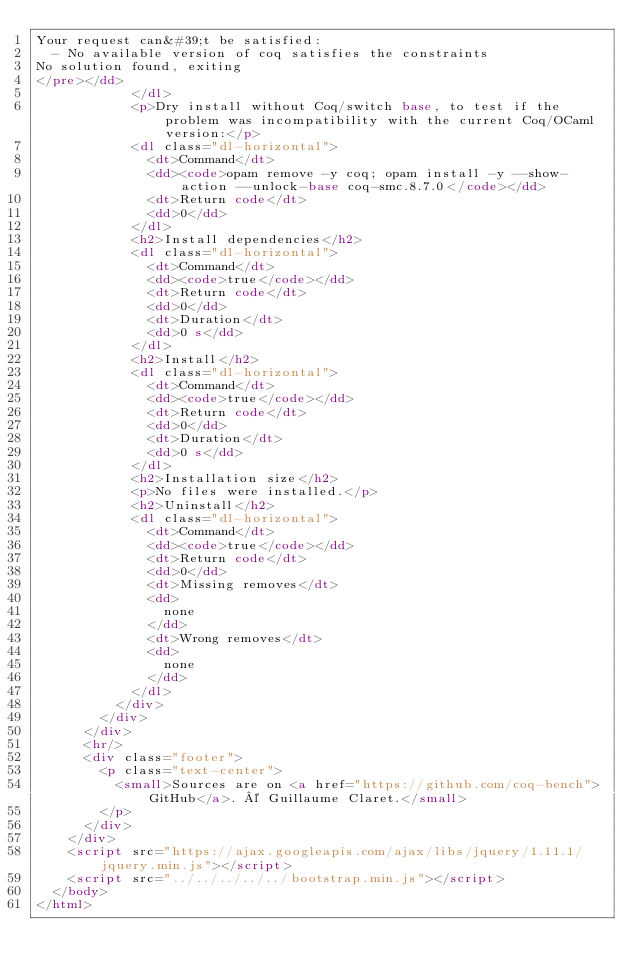Convert code to text. <code><loc_0><loc_0><loc_500><loc_500><_HTML_>Your request can&#39;t be satisfied:
  - No available version of coq satisfies the constraints
No solution found, exiting
</pre></dd>
            </dl>
            <p>Dry install without Coq/switch base, to test if the problem was incompatibility with the current Coq/OCaml version:</p>
            <dl class="dl-horizontal">
              <dt>Command</dt>
              <dd><code>opam remove -y coq; opam install -y --show-action --unlock-base coq-smc.8.7.0</code></dd>
              <dt>Return code</dt>
              <dd>0</dd>
            </dl>
            <h2>Install dependencies</h2>
            <dl class="dl-horizontal">
              <dt>Command</dt>
              <dd><code>true</code></dd>
              <dt>Return code</dt>
              <dd>0</dd>
              <dt>Duration</dt>
              <dd>0 s</dd>
            </dl>
            <h2>Install</h2>
            <dl class="dl-horizontal">
              <dt>Command</dt>
              <dd><code>true</code></dd>
              <dt>Return code</dt>
              <dd>0</dd>
              <dt>Duration</dt>
              <dd>0 s</dd>
            </dl>
            <h2>Installation size</h2>
            <p>No files were installed.</p>
            <h2>Uninstall</h2>
            <dl class="dl-horizontal">
              <dt>Command</dt>
              <dd><code>true</code></dd>
              <dt>Return code</dt>
              <dd>0</dd>
              <dt>Missing removes</dt>
              <dd>
                none
              </dd>
              <dt>Wrong removes</dt>
              <dd>
                none
              </dd>
            </dl>
          </div>
        </div>
      </div>
      <hr/>
      <div class="footer">
        <p class="text-center">
          <small>Sources are on <a href="https://github.com/coq-bench">GitHub</a>. © Guillaume Claret.</small>
        </p>
      </div>
    </div>
    <script src="https://ajax.googleapis.com/ajax/libs/jquery/1.11.1/jquery.min.js"></script>
    <script src="../../../../../bootstrap.min.js"></script>
  </body>
</html>
</code> 